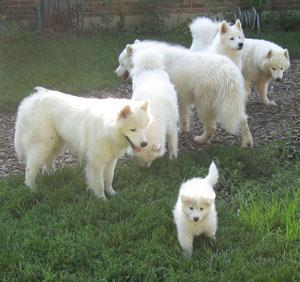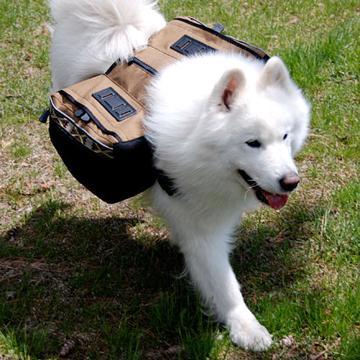The first image is the image on the left, the second image is the image on the right. Analyze the images presented: Is the assertion "At least one dog is sitting and one image has exactly 2 dogs." valid? Answer yes or no. No. The first image is the image on the left, the second image is the image on the right. Considering the images on both sides, is "There is a ball or a backpack in atleast one of the pictures." valid? Answer yes or no. Yes. 